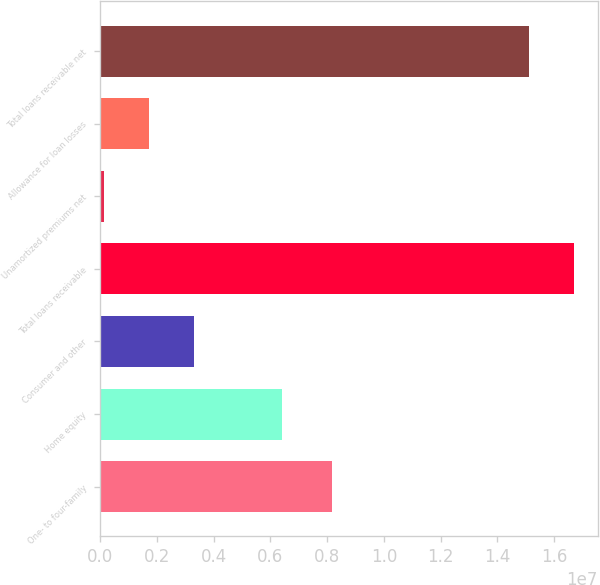Convert chart to OTSL. <chart><loc_0><loc_0><loc_500><loc_500><bar_chart><fcel>One- to four-family<fcel>Home equity<fcel>Consumer and other<fcel>Total loans receivable<fcel>Unamortized premiums net<fcel>Allowance for loan losses<fcel>Total loans receivable net<nl><fcel>8.17033e+06<fcel>6.41031e+06<fcel>3.30805e+06<fcel>1.67114e+07<fcel>129050<fcel>1.71855e+06<fcel>1.51219e+07<nl></chart> 